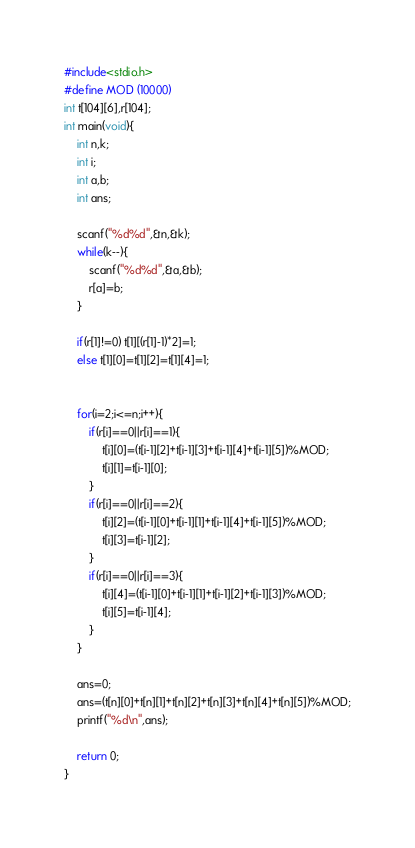Convert code to text. <code><loc_0><loc_0><loc_500><loc_500><_C_>#include<stdio.h>
#define MOD (10000)
int t[104][6],r[104];
int main(void){
    int n,k;
    int i;
    int a,b;
    int ans;

    scanf("%d%d",&n,&k);
    while(k--){
        scanf("%d%d",&a,&b);
        r[a]=b;
    }

    if(r[1]!=0) t[1][(r[1]-1)*2]=1;
    else t[1][0]=t[1][2]=t[1][4]=1;


    for(i=2;i<=n;i++){
        if(r[i]==0||r[i]==1){
            t[i][0]=(t[i-1][2]+t[i-1][3]+t[i-1][4]+t[i-1][5])%MOD;
            t[i][1]=t[i-1][0];
        }
        if(r[i]==0||r[i]==2){
            t[i][2]=(t[i-1][0]+t[i-1][1]+t[i-1][4]+t[i-1][5])%MOD;
            t[i][3]=t[i-1][2];
        }
        if(r[i]==0||r[i]==3){
            t[i][4]=(t[i-1][0]+t[i-1][1]+t[i-1][2]+t[i-1][3])%MOD;
            t[i][5]=t[i-1][4];
        }
    }

    ans=0;
    ans=(t[n][0]+t[n][1]+t[n][2]+t[n][3]+t[n][4]+t[n][5])%MOD;
    printf("%d\n",ans);

    return 0;
}</code> 